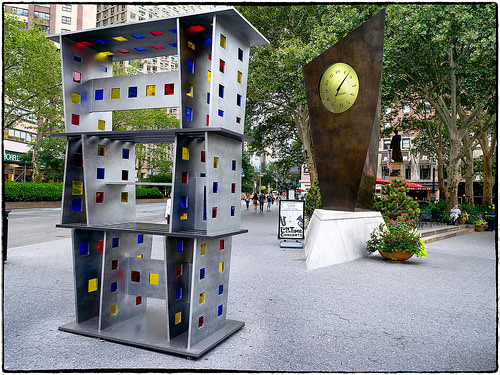<image>
Is there a clock next to the statue? No. The clock is not positioned next to the statue. They are located in different areas of the scene. 